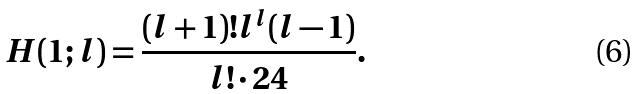Convert formula to latex. <formula><loc_0><loc_0><loc_500><loc_500>H ( 1 ; l ) = \frac { ( l + 1 ) ! l ^ { l } ( l - 1 ) } { l ! \cdot 2 4 } .</formula> 